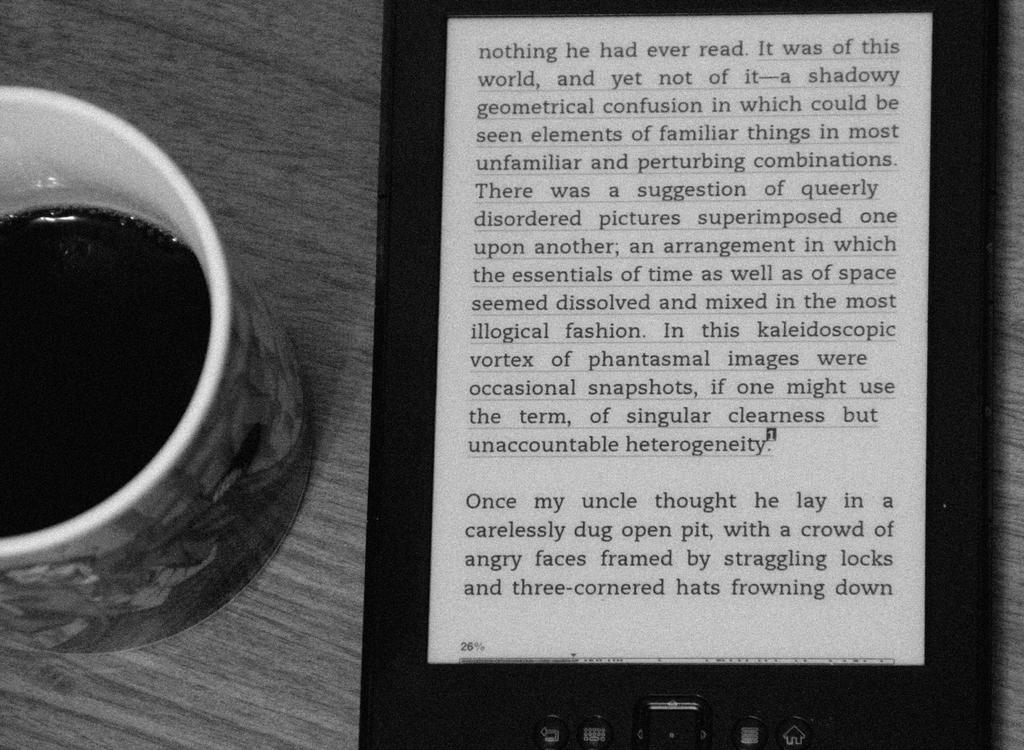<image>
Present a compact description of the photo's key features. A mug of coffee is placed on a table next to an electronic device displaying a story about someones uncle. 